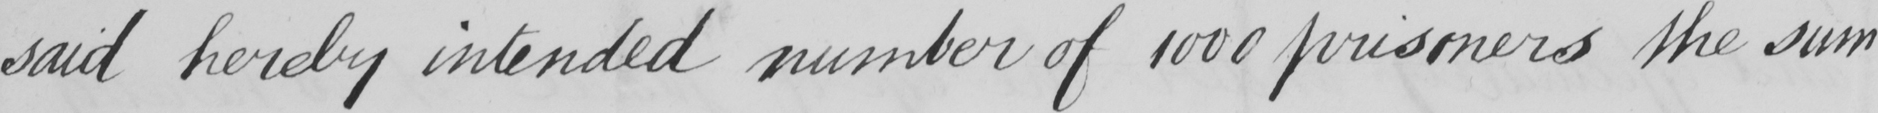Please provide the text content of this handwritten line. said hereby intended number of 1000 prisoners the sum 